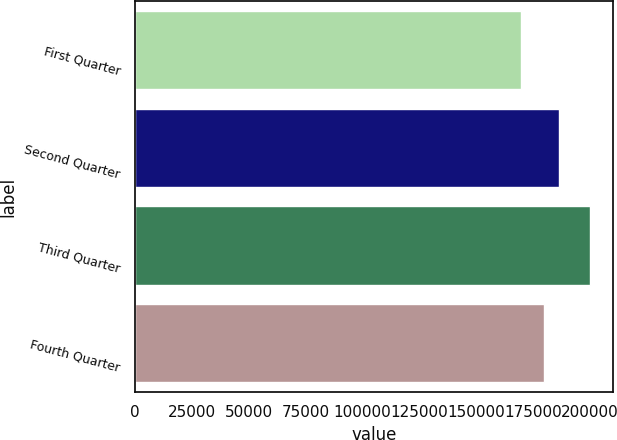Convert chart. <chart><loc_0><loc_0><loc_500><loc_500><bar_chart><fcel>First Quarter<fcel>Second Quarter<fcel>Third Quarter<fcel>Fourth Quarter<nl><fcel>169767<fcel>186337<fcel>200036<fcel>179728<nl></chart> 